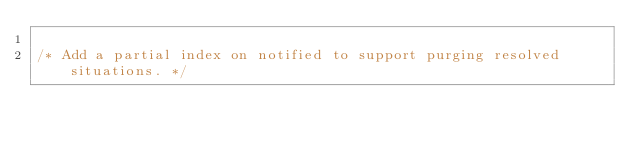<code> <loc_0><loc_0><loc_500><loc_500><_SQL_>
/* Add a partial index on notified to support purging resolved situations. */</code> 